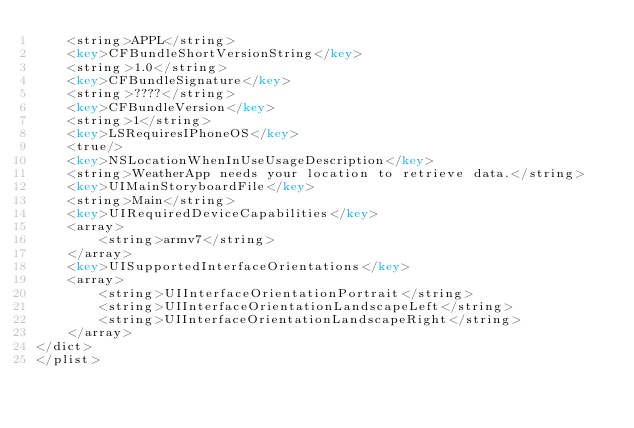<code> <loc_0><loc_0><loc_500><loc_500><_XML_>	<string>APPL</string>
	<key>CFBundleShortVersionString</key>
	<string>1.0</string>
	<key>CFBundleSignature</key>
	<string>????</string>
	<key>CFBundleVersion</key>
	<string>1</string>
	<key>LSRequiresIPhoneOS</key>
	<true/>
	<key>NSLocationWhenInUseUsageDescription</key>
	<string>WeatherApp needs your location to retrieve data.</string>
	<key>UIMainStoryboardFile</key>
	<string>Main</string>
	<key>UIRequiredDeviceCapabilities</key>
	<array>
		<string>armv7</string>
	</array>
	<key>UISupportedInterfaceOrientations</key>
	<array>
		<string>UIInterfaceOrientationPortrait</string>
		<string>UIInterfaceOrientationLandscapeLeft</string>
		<string>UIInterfaceOrientationLandscapeRight</string>
	</array>
</dict>
</plist>
</code> 